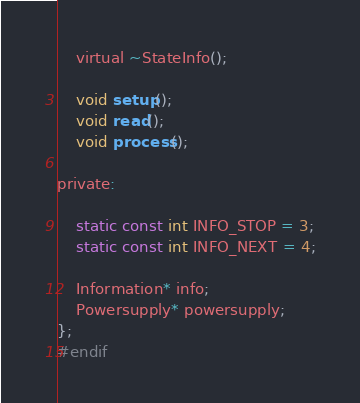Convert code to text. <code><loc_0><loc_0><loc_500><loc_500><_C_>	virtual ~StateInfo();

	void setup();
	void read();
	void process();

private:

	static const int INFO_STOP = 3;
	static const int INFO_NEXT = 4;

	Information* info;
	Powersupply* powersupply;
};
#endif
</code> 